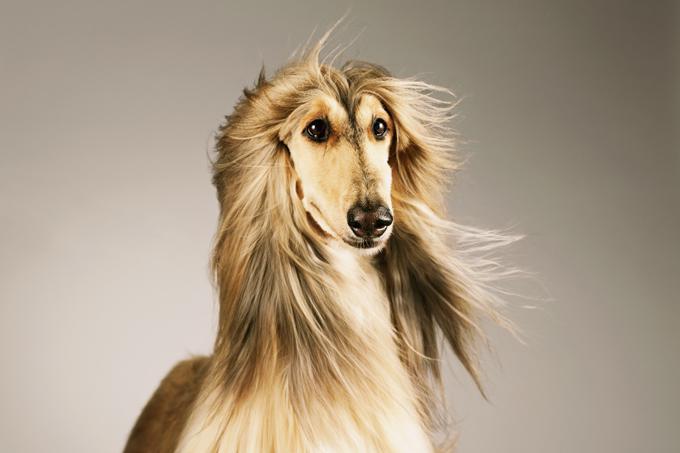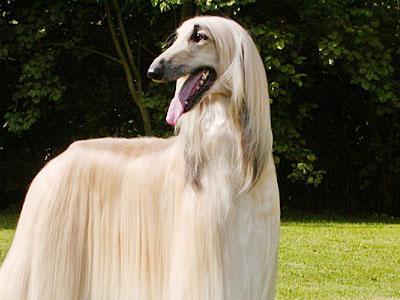The first image is the image on the left, the second image is the image on the right. Analyze the images presented: Is the assertion "Only the dogs head can be seen in the image on the right." valid? Answer yes or no. No. 